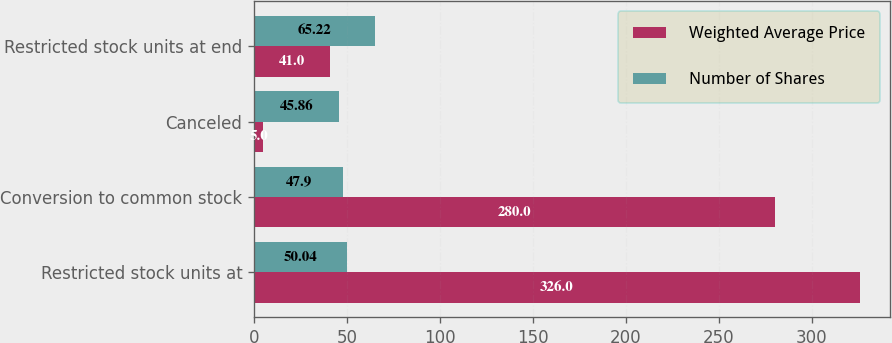Convert chart to OTSL. <chart><loc_0><loc_0><loc_500><loc_500><stacked_bar_chart><ecel><fcel>Restricted stock units at<fcel>Conversion to common stock<fcel>Canceled<fcel>Restricted stock units at end<nl><fcel>Weighted Average Price<fcel>326<fcel>280<fcel>5<fcel>41<nl><fcel>Number of Shares<fcel>50.04<fcel>47.9<fcel>45.86<fcel>65.22<nl></chart> 